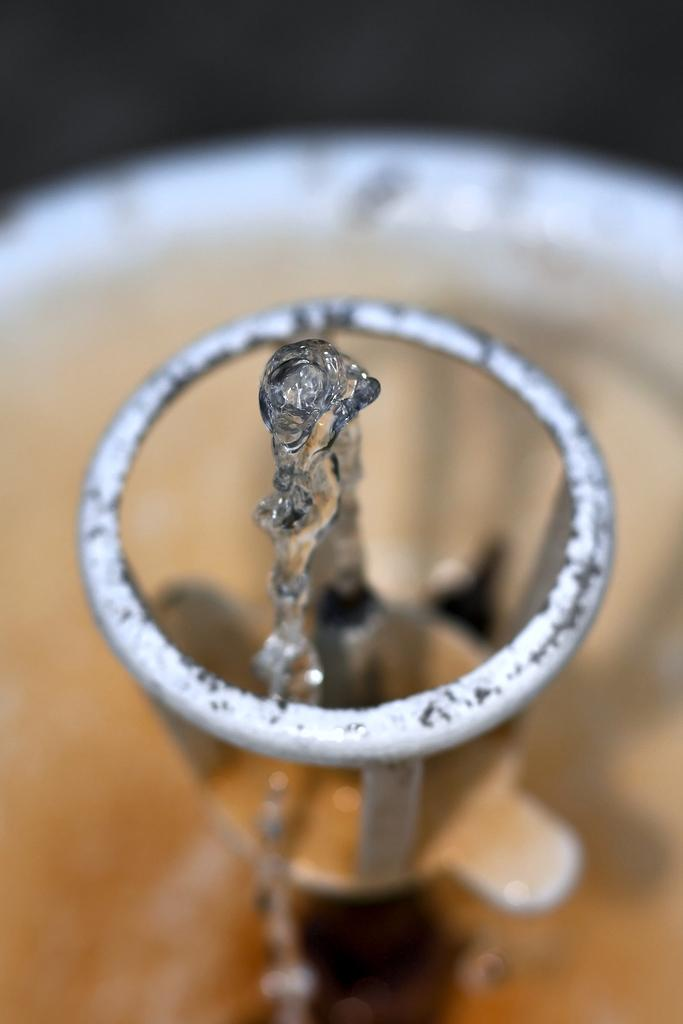What is the main subject of the image? The main subject of the image is a water sprinkler. What type of underwear is hanging on the water sprinkler in the image? There is no underwear present in the image; the main subject is a water sprinkler. What vegetables can be seen growing near the water sprinkler in the image? There is no reference to vegetables or any plants in the image; it only features a water sprinkler. 